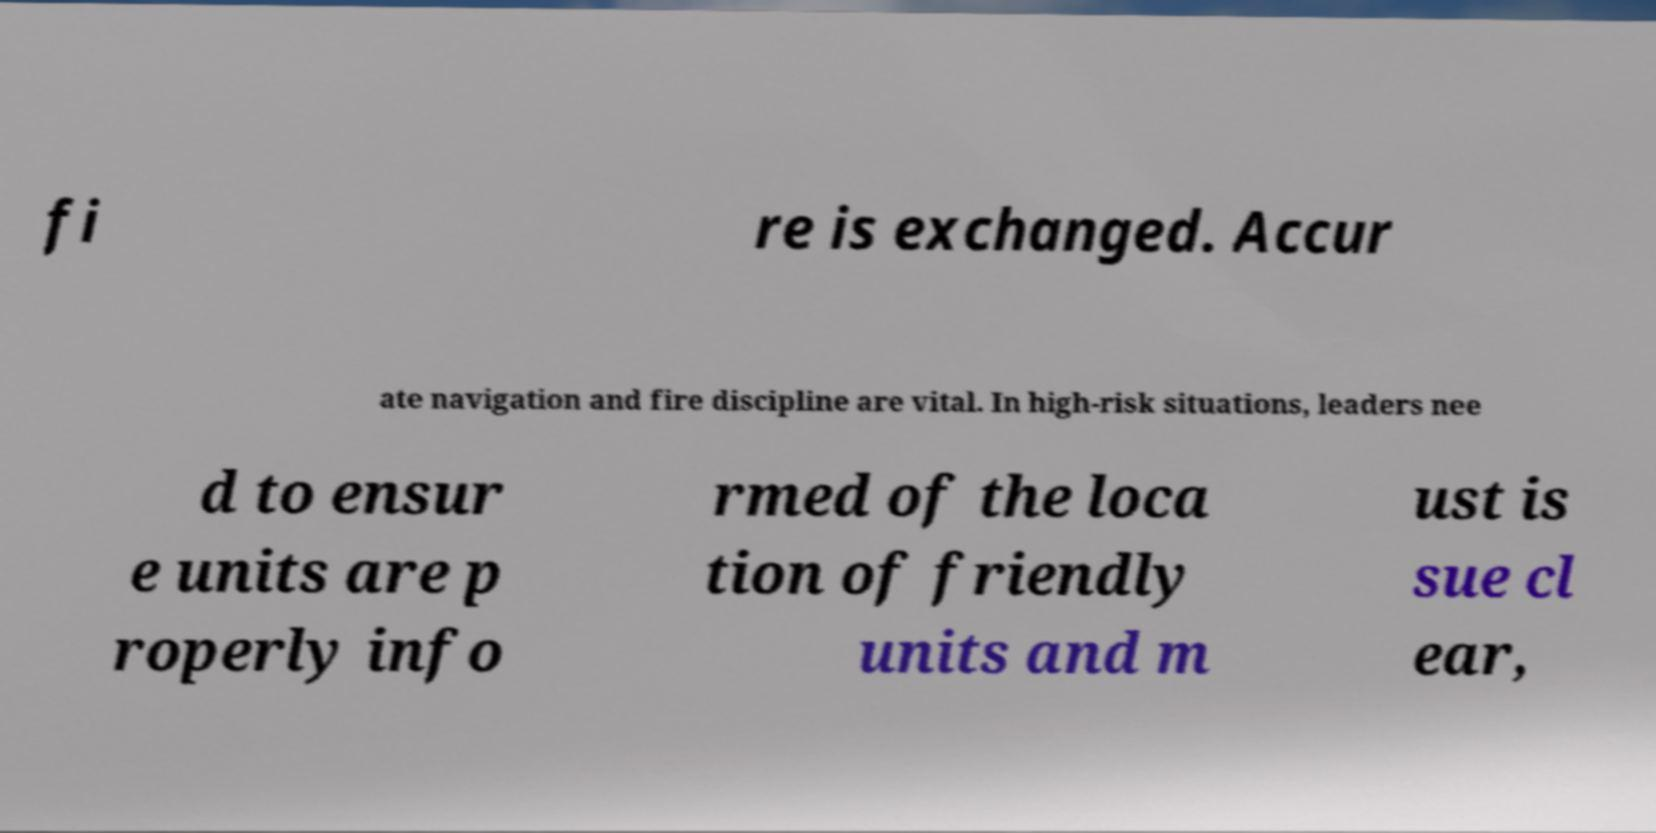What messages or text are displayed in this image? I need them in a readable, typed format. fi re is exchanged. Accur ate navigation and fire discipline are vital. In high-risk situations, leaders nee d to ensur e units are p roperly info rmed of the loca tion of friendly units and m ust is sue cl ear, 